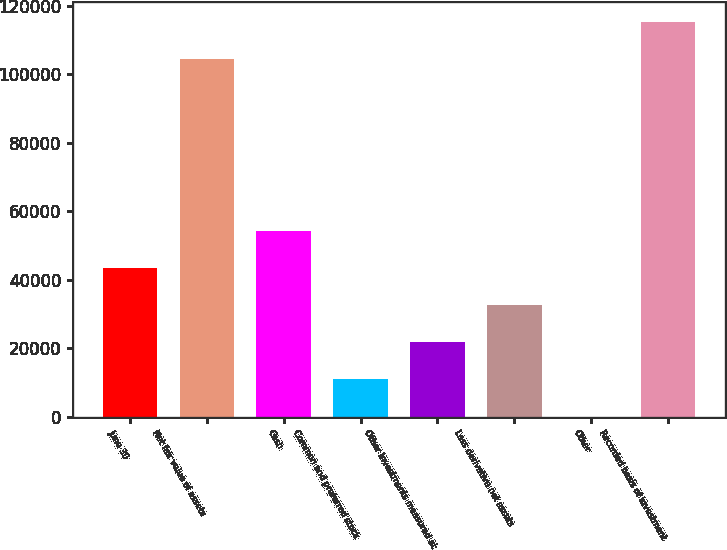Convert chart to OTSL. <chart><loc_0><loc_0><loc_500><loc_500><bar_chart><fcel>June 30<fcel>Net fair value of assets<fcel>Cash<fcel>Common and preferred stock<fcel>Other investments measured at<fcel>Less derivative net assets<fcel>Other<fcel>Recorded basis of investment<nl><fcel>43424<fcel>104369<fcel>54279<fcel>10859<fcel>21714<fcel>32569<fcel>4<fcel>115224<nl></chart> 